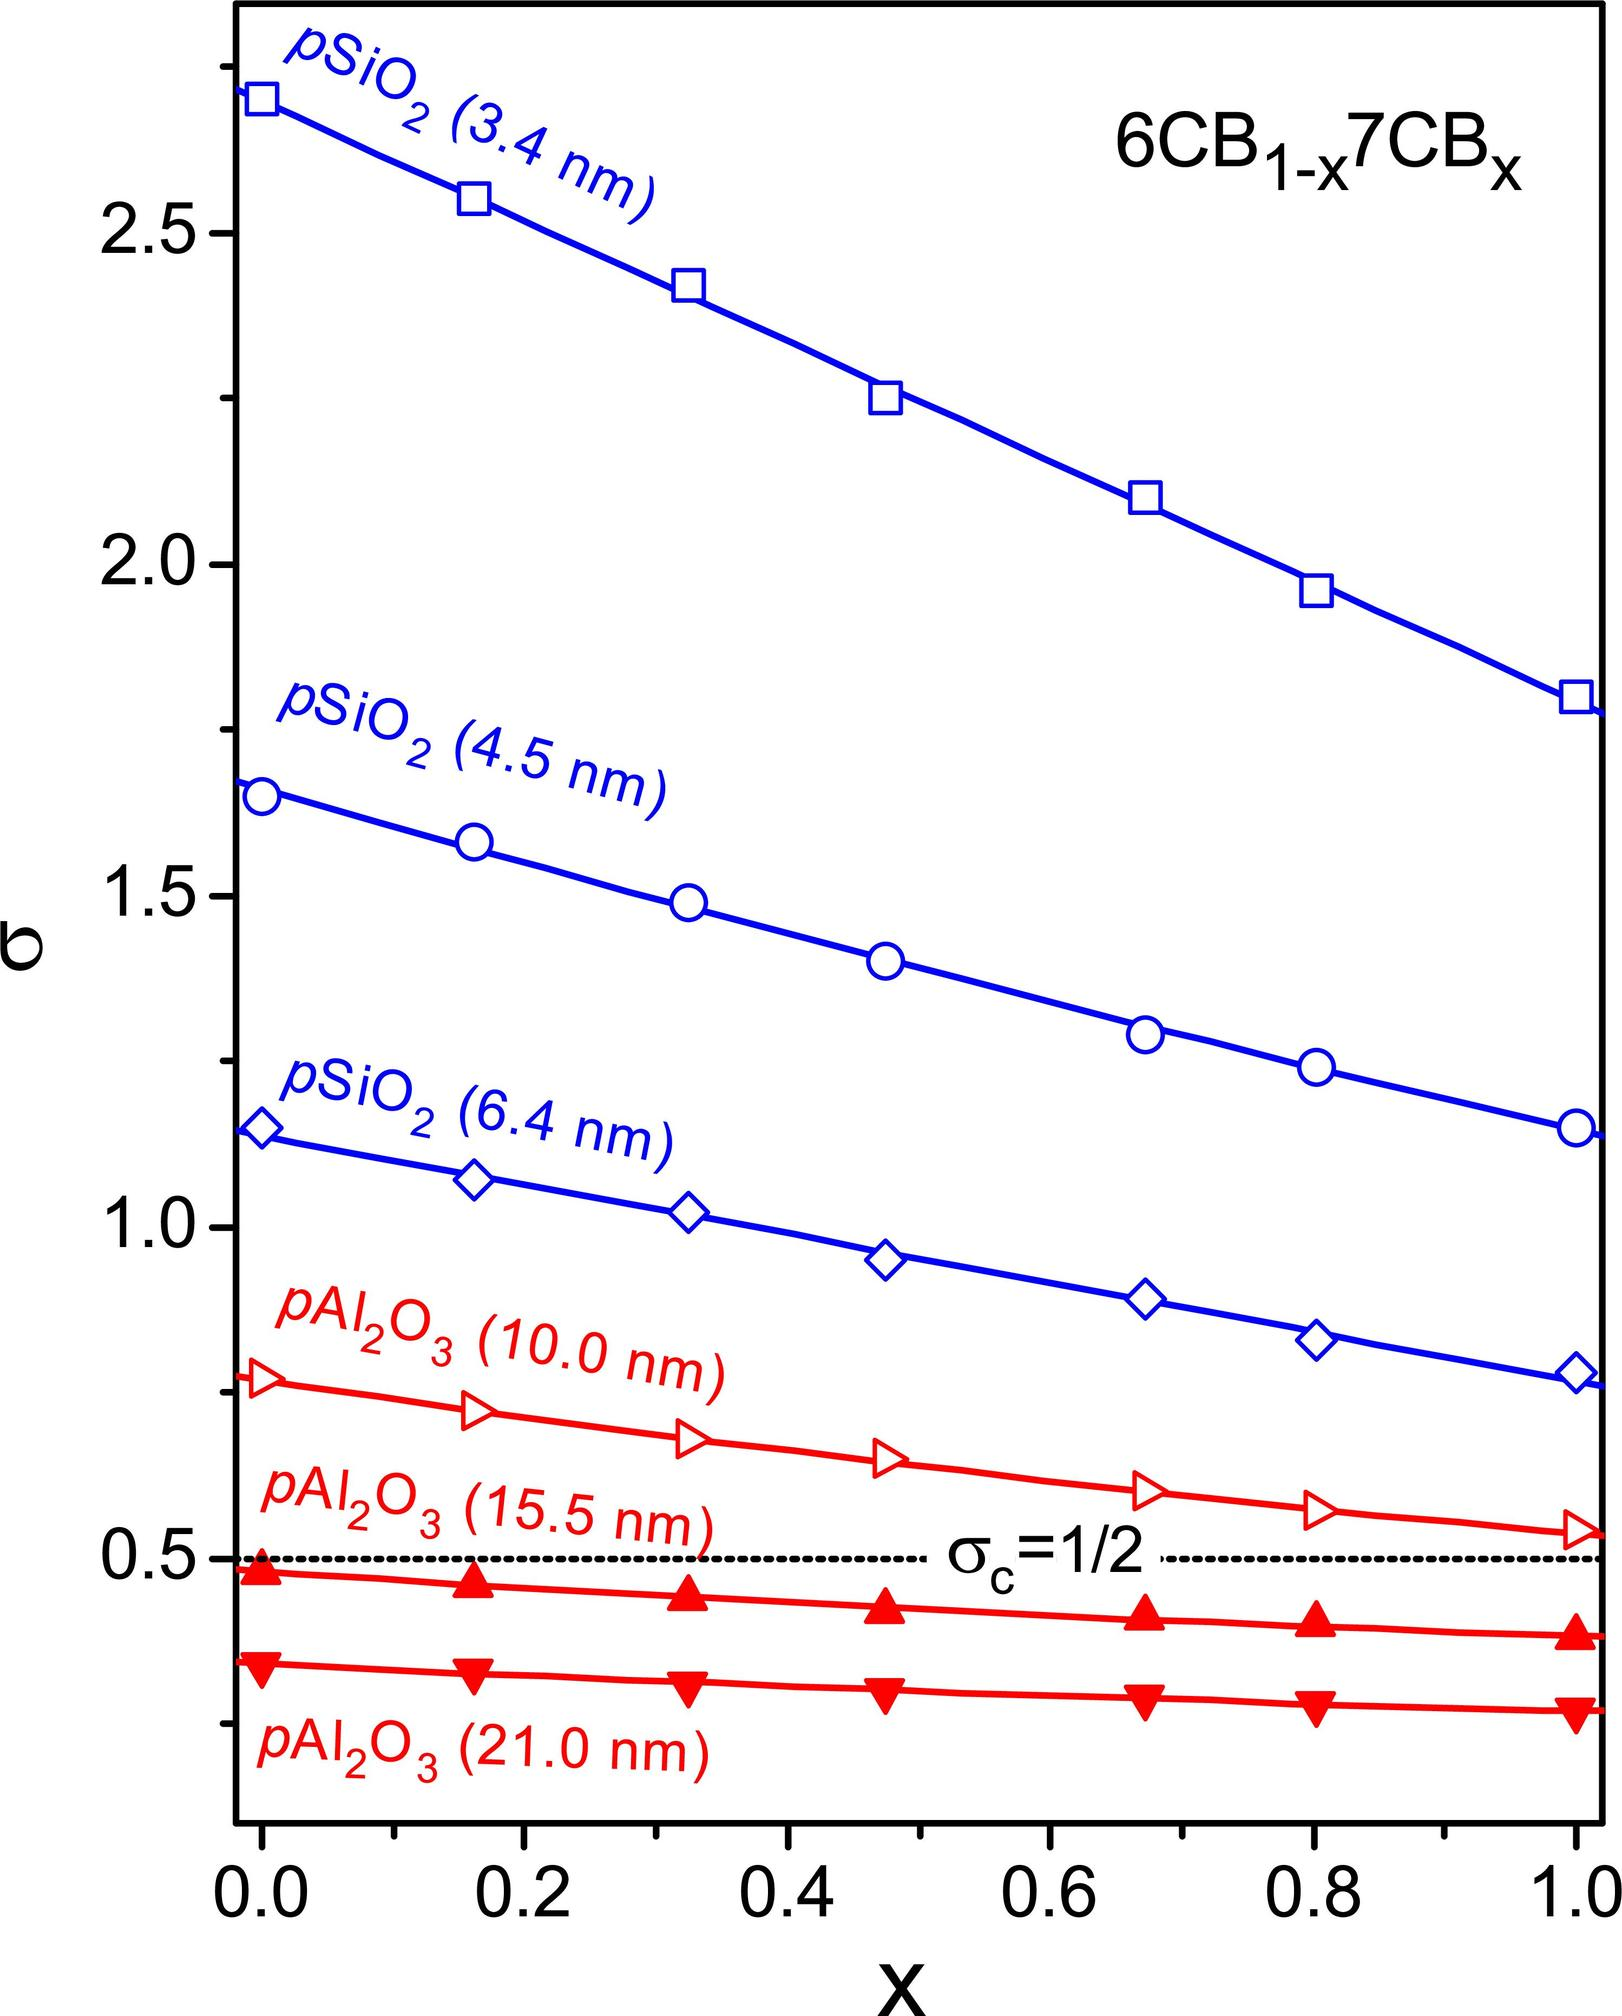What does the parameter 'x' in the figure title '6CB1-x7CBx' most likely represent? A) The concentration of 6CB in moles. B) The fraction of 7CB in the mixture with 6CB. C) The temperature at which the measurements were taken. D) The number of experiments conducted. In the context of the provided graph, the parameter 'x' in the title '6CB1-x7CBx' most certainly denotes the fraction of the compound 7CB within the 6CB/7CB mixture. This interpretation is further supported by the graph's x-axis, which scales from 0 to 1, a common representation for factional composition in mixtures. The lines and markers on the graph appear to represent different particle sizes of materials, such as pSiO2 (polymerized Silica) and pAl2O3 (polymeric Alumina), each with varying fractions of 7CB as indicated by 'x'. This information is crucial for scientists and researchers in understanding the phase behavior of such mixtures as the proportion of one component changes. Hence, the most accurate answer is B, which aligns with the scientific convention of denoting mixture ratios. 